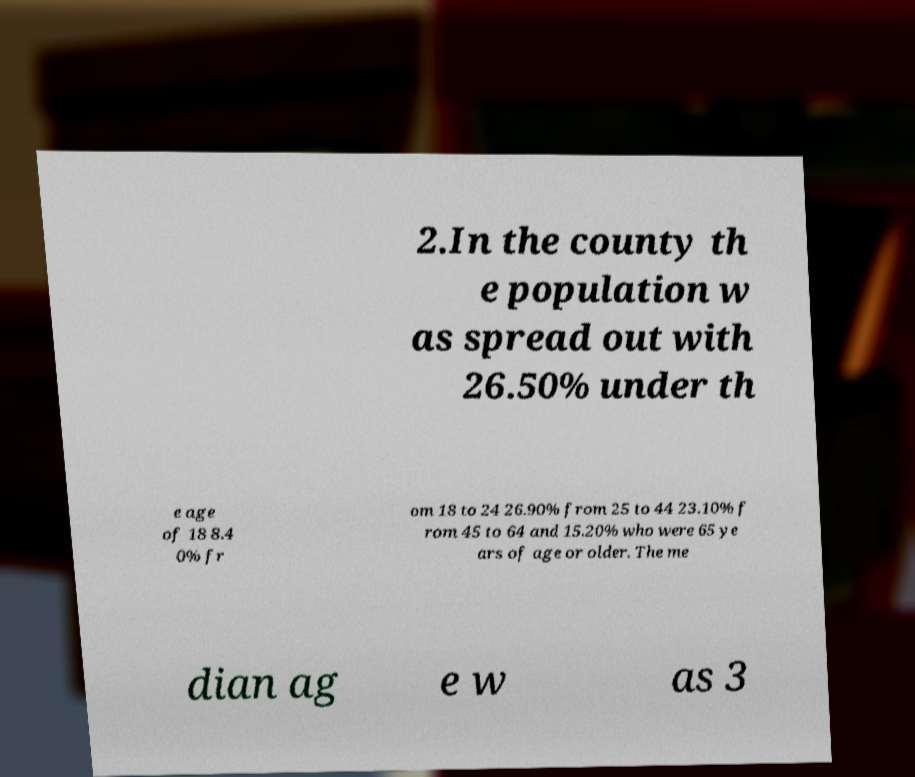Can you read and provide the text displayed in the image?This photo seems to have some interesting text. Can you extract and type it out for me? 2.In the county th e population w as spread out with 26.50% under th e age of 18 8.4 0% fr om 18 to 24 26.90% from 25 to 44 23.10% f rom 45 to 64 and 15.20% who were 65 ye ars of age or older. The me dian ag e w as 3 